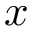Convert formula to latex. <formula><loc_0><loc_0><loc_500><loc_500>x</formula> 